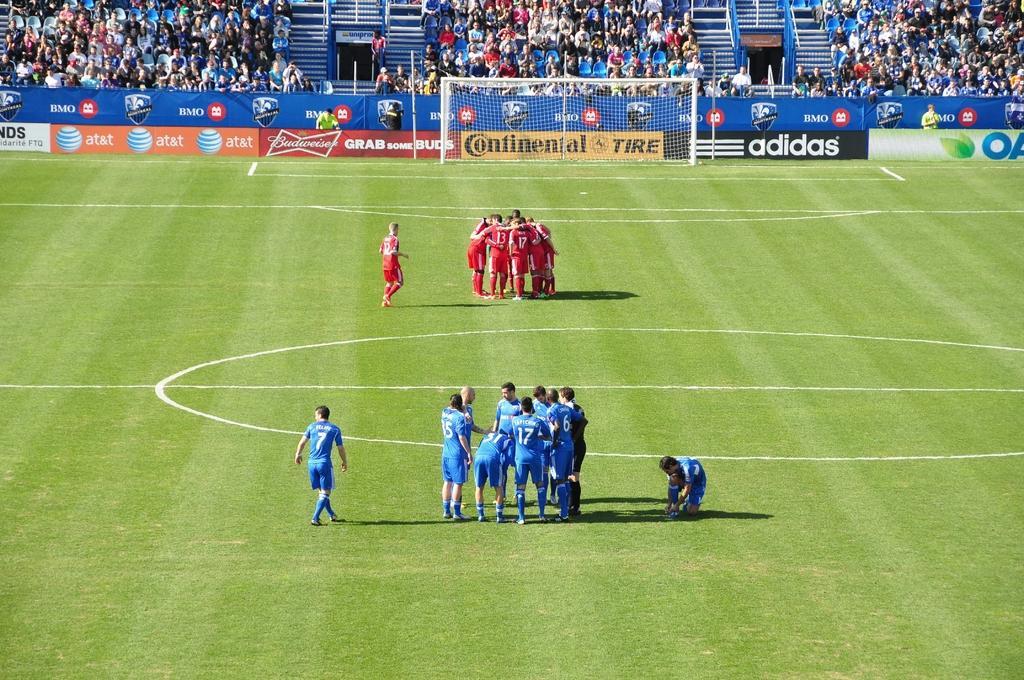Please provide a concise description of this image. In this image we can see a group of people on the ground. On the backside we can see a goal post, fence, banners with some text on them, metal poles and a group of audience. 